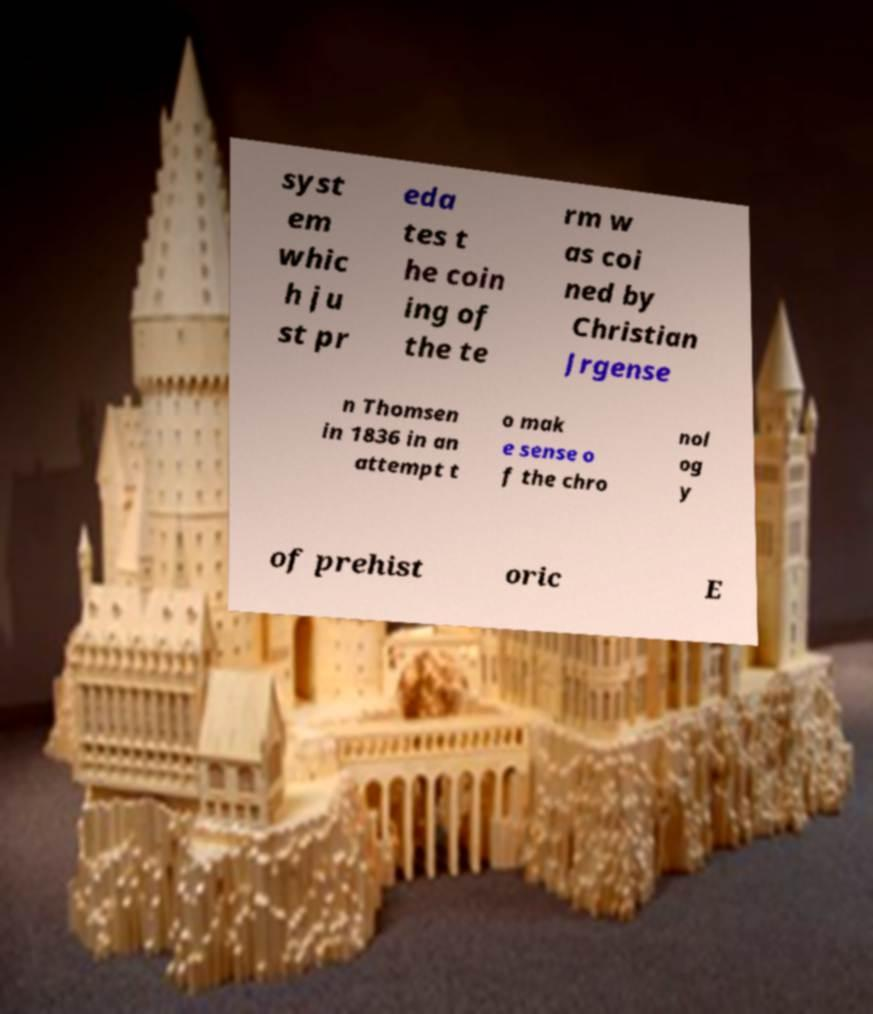Please identify and transcribe the text found in this image. syst em whic h ju st pr eda tes t he coin ing of the te rm w as coi ned by Christian Jrgense n Thomsen in 1836 in an attempt t o mak e sense o f the chro nol og y of prehist oric E 